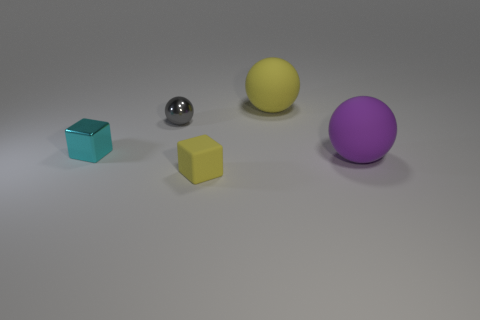Add 4 blue rubber blocks. How many objects exist? 9 Subtract all cubes. How many objects are left? 3 Add 1 tiny matte objects. How many tiny matte objects exist? 2 Subtract 0 green balls. How many objects are left? 5 Subtract all yellow rubber spheres. Subtract all shiny things. How many objects are left? 2 Add 5 spheres. How many spheres are left? 8 